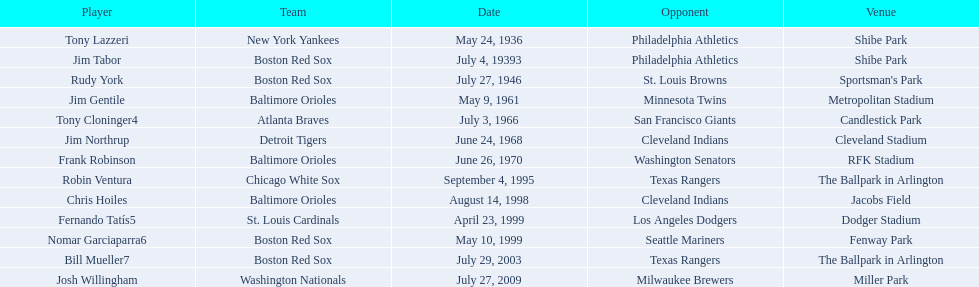What are the designations of all the players? Tony Lazzeri, Jim Tabor, Rudy York, Jim Gentile, Tony Cloninger4, Jim Northrup, Frank Robinson, Robin Ventura, Chris Hoiles, Fernando Tatís5, Nomar Garciaparra6, Bill Mueller7, Josh Willingham. What are the designations of all the teams with home run records? New York Yankees, Boston Red Sox, Baltimore Orioles, Atlanta Braves, Detroit Tigers, Chicago White Sox, St. Louis Cardinals, Washington Nationals. Which player took part for the new york yankees? Tony Lazzeri. 